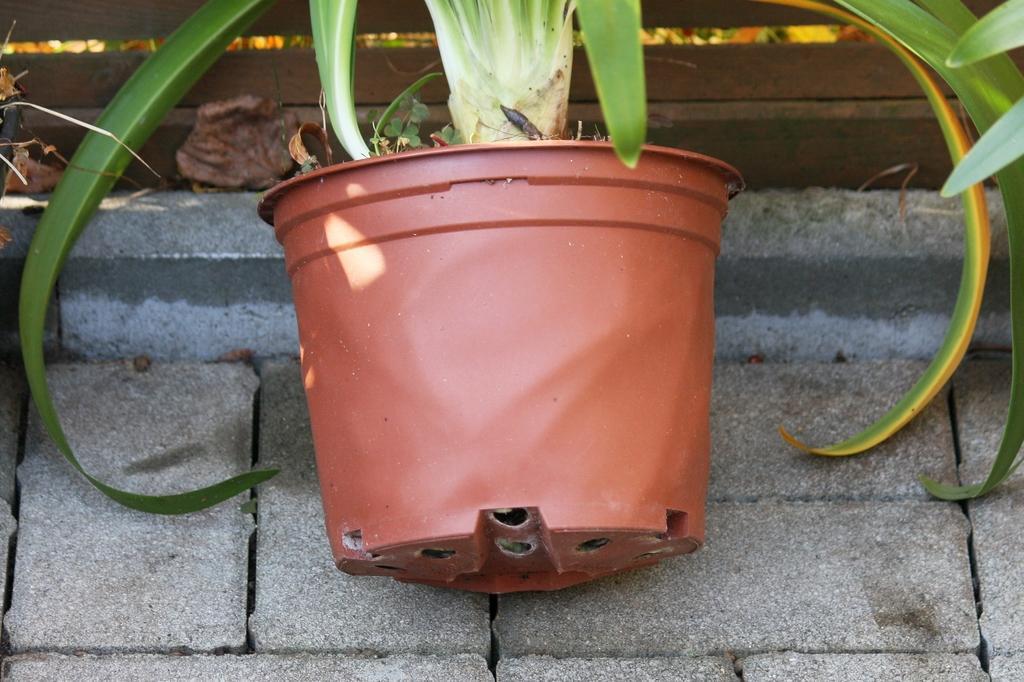Please provide a concise description of this image. In this image we can see one pot with plants on the floor, some dried leaves on the ground, it looks like a wooden fence in the background and it looks like some plants behind the wooden fence. 